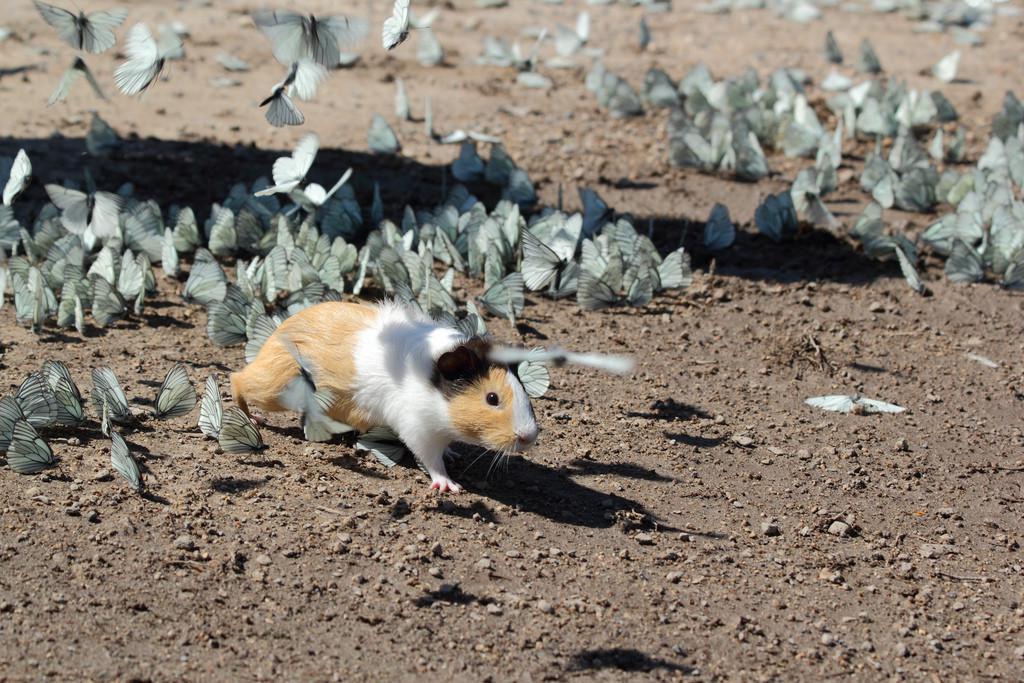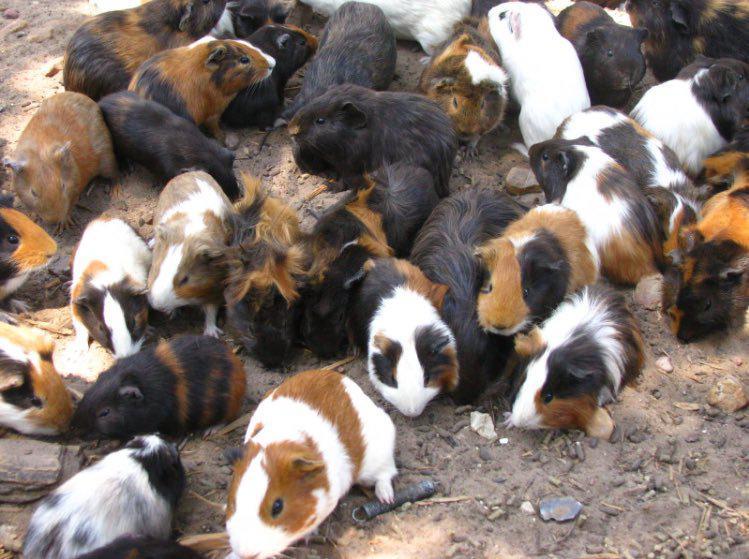The first image is the image on the left, the second image is the image on the right. Analyze the images presented: Is the assertion "Multiple hamsters surround a pile of leafy greens in at least one image." valid? Answer yes or no. No. The first image is the image on the left, the second image is the image on the right. Analyze the images presented: Is the assertion "One image shows exactly one guinea pig surrounded by butterflies while the other image shows several guinea pigs." valid? Answer yes or no. Yes. 